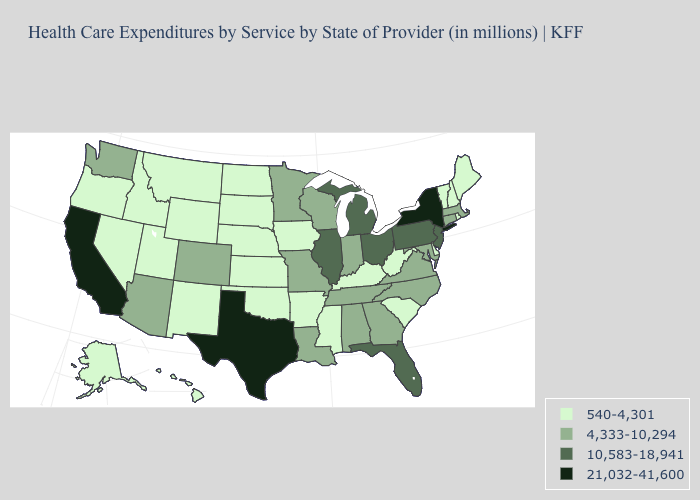What is the value of Pennsylvania?
Keep it brief. 10,583-18,941. Name the states that have a value in the range 540-4,301?
Keep it brief. Alaska, Arkansas, Delaware, Hawaii, Idaho, Iowa, Kansas, Kentucky, Maine, Mississippi, Montana, Nebraska, Nevada, New Hampshire, New Mexico, North Dakota, Oklahoma, Oregon, Rhode Island, South Carolina, South Dakota, Utah, Vermont, West Virginia, Wyoming. Name the states that have a value in the range 10,583-18,941?
Be succinct. Florida, Illinois, Michigan, New Jersey, Ohio, Pennsylvania. What is the lowest value in the MidWest?
Answer briefly. 540-4,301. What is the highest value in the MidWest ?
Answer briefly. 10,583-18,941. Name the states that have a value in the range 540-4,301?
Short answer required. Alaska, Arkansas, Delaware, Hawaii, Idaho, Iowa, Kansas, Kentucky, Maine, Mississippi, Montana, Nebraska, Nevada, New Hampshire, New Mexico, North Dakota, Oklahoma, Oregon, Rhode Island, South Carolina, South Dakota, Utah, Vermont, West Virginia, Wyoming. Does Colorado have the same value as West Virginia?
Write a very short answer. No. Name the states that have a value in the range 10,583-18,941?
Answer briefly. Florida, Illinois, Michigan, New Jersey, Ohio, Pennsylvania. Does the map have missing data?
Give a very brief answer. No. Does Texas have the highest value in the USA?
Short answer required. Yes. Name the states that have a value in the range 540-4,301?
Quick response, please. Alaska, Arkansas, Delaware, Hawaii, Idaho, Iowa, Kansas, Kentucky, Maine, Mississippi, Montana, Nebraska, Nevada, New Hampshire, New Mexico, North Dakota, Oklahoma, Oregon, Rhode Island, South Carolina, South Dakota, Utah, Vermont, West Virginia, Wyoming. What is the highest value in states that border New Jersey?
Write a very short answer. 21,032-41,600. What is the lowest value in the MidWest?
Answer briefly. 540-4,301. Name the states that have a value in the range 10,583-18,941?
Be succinct. Florida, Illinois, Michigan, New Jersey, Ohio, Pennsylvania. What is the lowest value in states that border Tennessee?
Short answer required. 540-4,301. 